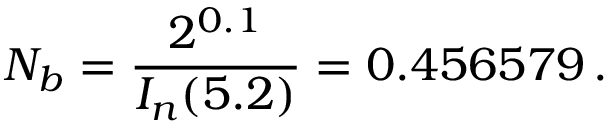<formula> <loc_0><loc_0><loc_500><loc_500>N _ { b } = \frac { 2 ^ { 0 . 1 } } { I _ { n } ( 5 . 2 ) } = 0 . 4 5 6 5 7 9 \, .</formula> 